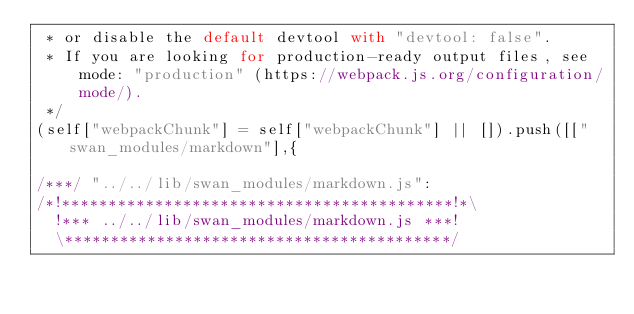Convert code to text. <code><loc_0><loc_0><loc_500><loc_500><_JavaScript_> * or disable the default devtool with "devtool: false".
 * If you are looking for production-ready output files, see mode: "production" (https://webpack.js.org/configuration/mode/).
 */
(self["webpackChunk"] = self["webpackChunk"] || []).push([["swan_modules/markdown"],{

/***/ "../../lib/swan_modules/markdown.js":
/*!******************************************!*\
  !*** ../../lib/swan_modules/markdown.js ***!
  \******************************************/</code> 